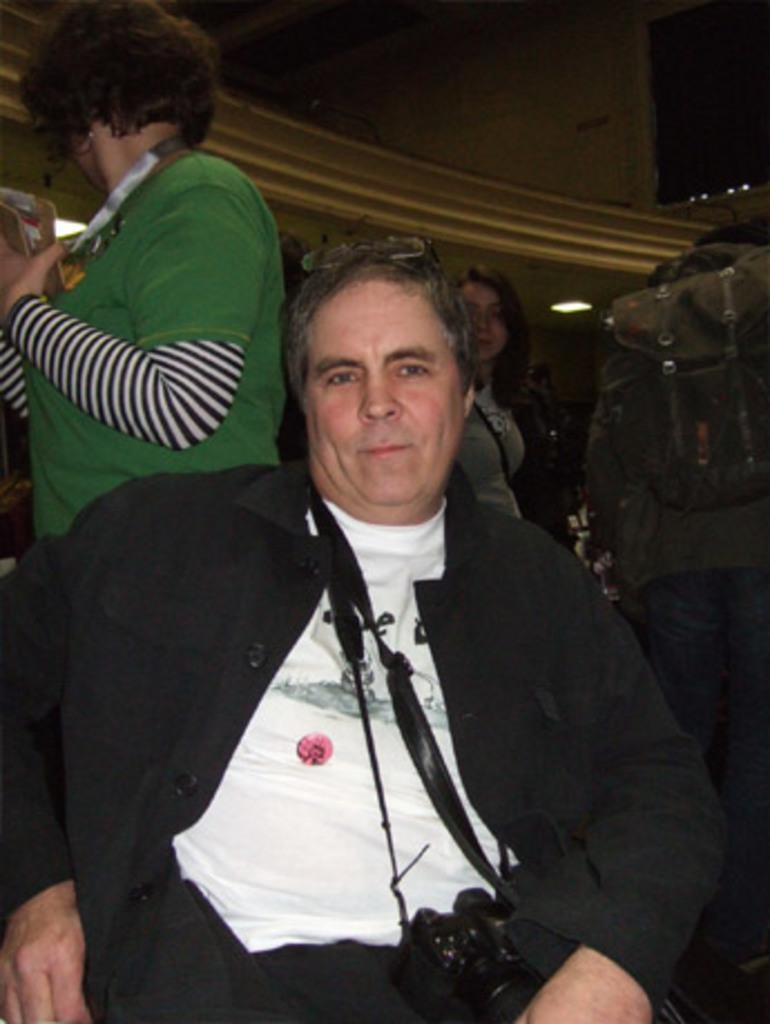What is the man in the image doing? The man is sitting in the image. Can you describe the surroundings of the man? There are people in the background of the image, and there is a wall visible. What type of bear can be seen holding a heart in the image? There is no bear or heart present in the image. 